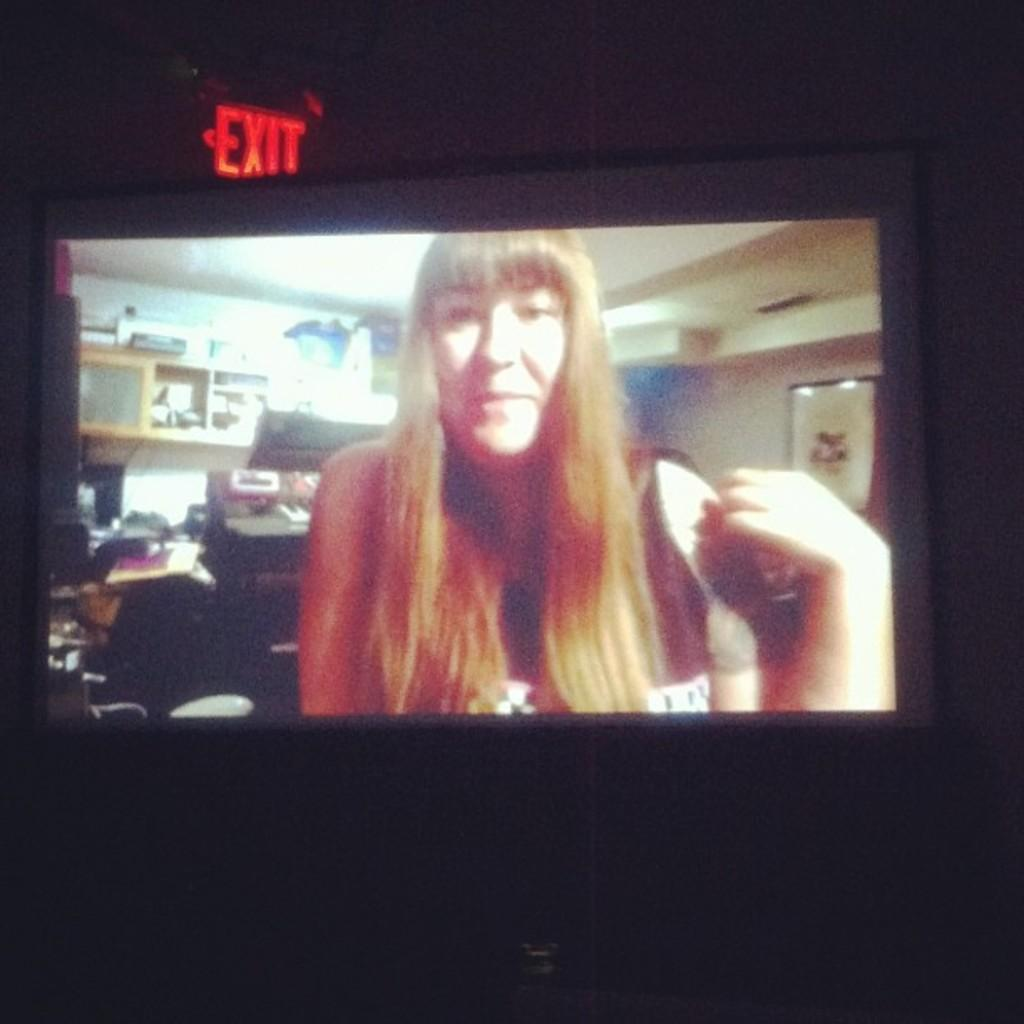Provide a one-sentence caption for the provided image. A projection screen shows a woman, just below an exit sign. 